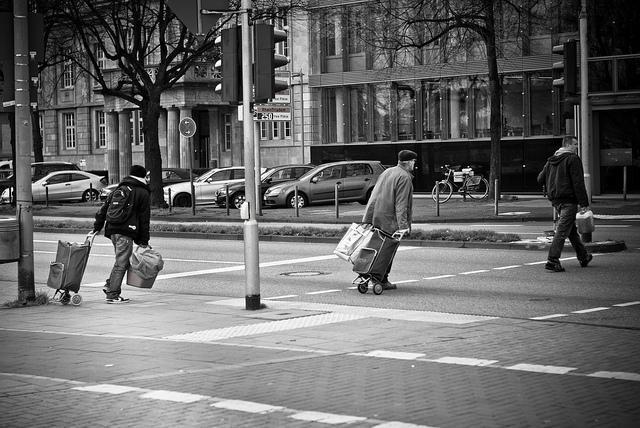How many people are in the road?
Give a very brief answer. 3. How many people are there?
Give a very brief answer. 3. How many cars are there?
Give a very brief answer. 2. How many people are in the picture?
Give a very brief answer. 3. 